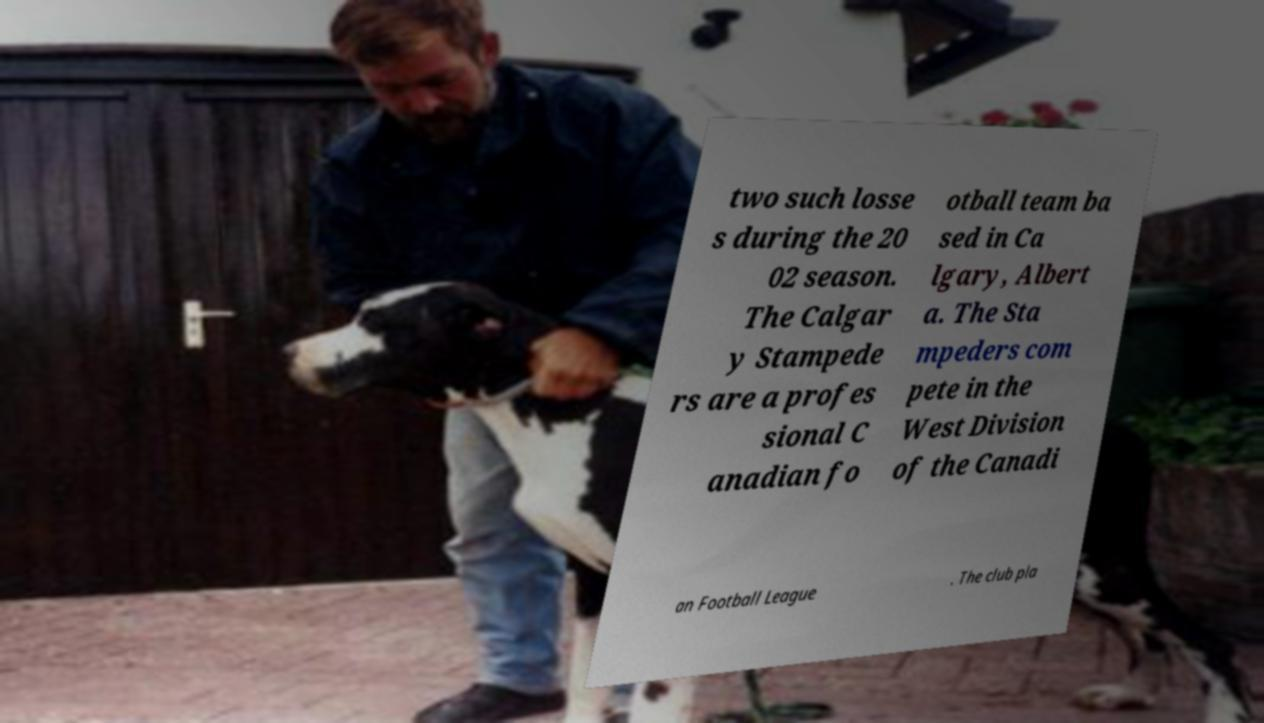For documentation purposes, I need the text within this image transcribed. Could you provide that? two such losse s during the 20 02 season. The Calgar y Stampede rs are a profes sional C anadian fo otball team ba sed in Ca lgary, Albert a. The Sta mpeders com pete in the West Division of the Canadi an Football League . The club pla 